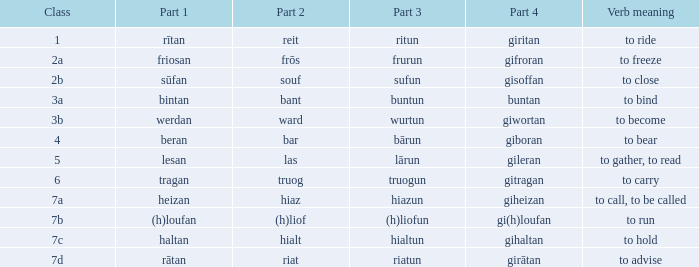What is the action definition of the term containing segment 2 "bant"? To bind. 